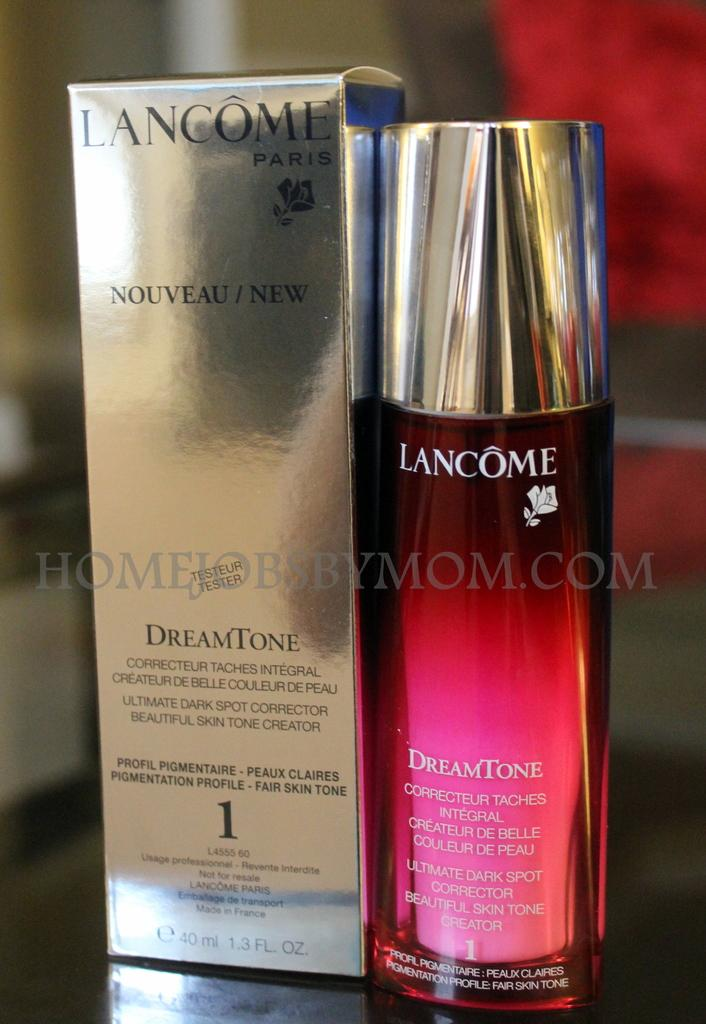<image>
Render a clear and concise summary of the photo. A bottle of LANCOME is sitting next to the box for the scent DreamTone 